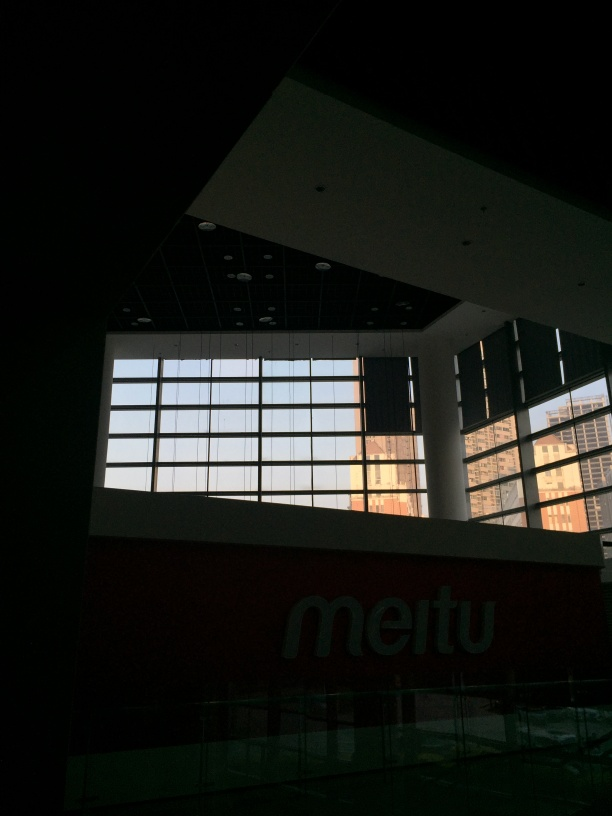How can the atmosphere or mood of this location be described? The image conveys a sense of calmness and solitude, emphasized by the absence of human activity and the spaciousness of the indoor area. The interplay of light and shadow, along with the cool green and blue hues from the windows, contributes to a serene and somewhat introspective mood. 